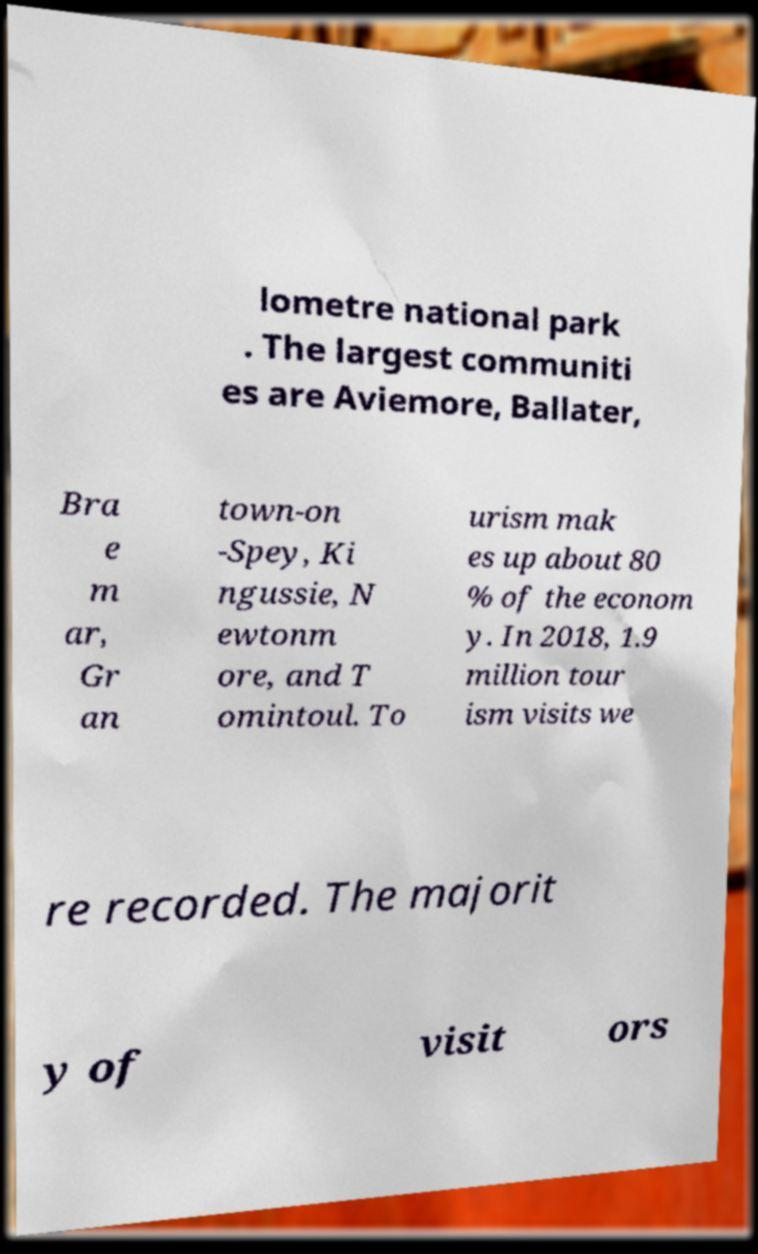For documentation purposes, I need the text within this image transcribed. Could you provide that? lometre national park . The largest communiti es are Aviemore, Ballater, Bra e m ar, Gr an town-on -Spey, Ki ngussie, N ewtonm ore, and T omintoul. To urism mak es up about 80 % of the econom y. In 2018, 1.9 million tour ism visits we re recorded. The majorit y of visit ors 